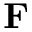Convert formula to latex. <formula><loc_0><loc_0><loc_500><loc_500>F</formula> 